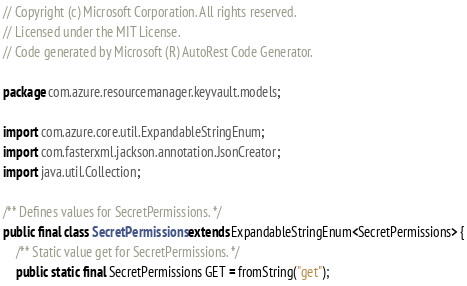<code> <loc_0><loc_0><loc_500><loc_500><_Java_>// Copyright (c) Microsoft Corporation. All rights reserved.
// Licensed under the MIT License.
// Code generated by Microsoft (R) AutoRest Code Generator.

package com.azure.resourcemanager.keyvault.models;

import com.azure.core.util.ExpandableStringEnum;
import com.fasterxml.jackson.annotation.JsonCreator;
import java.util.Collection;

/** Defines values for SecretPermissions. */
public final class SecretPermissions extends ExpandableStringEnum<SecretPermissions> {
    /** Static value get for SecretPermissions. */
    public static final SecretPermissions GET = fromString("get");
</code> 